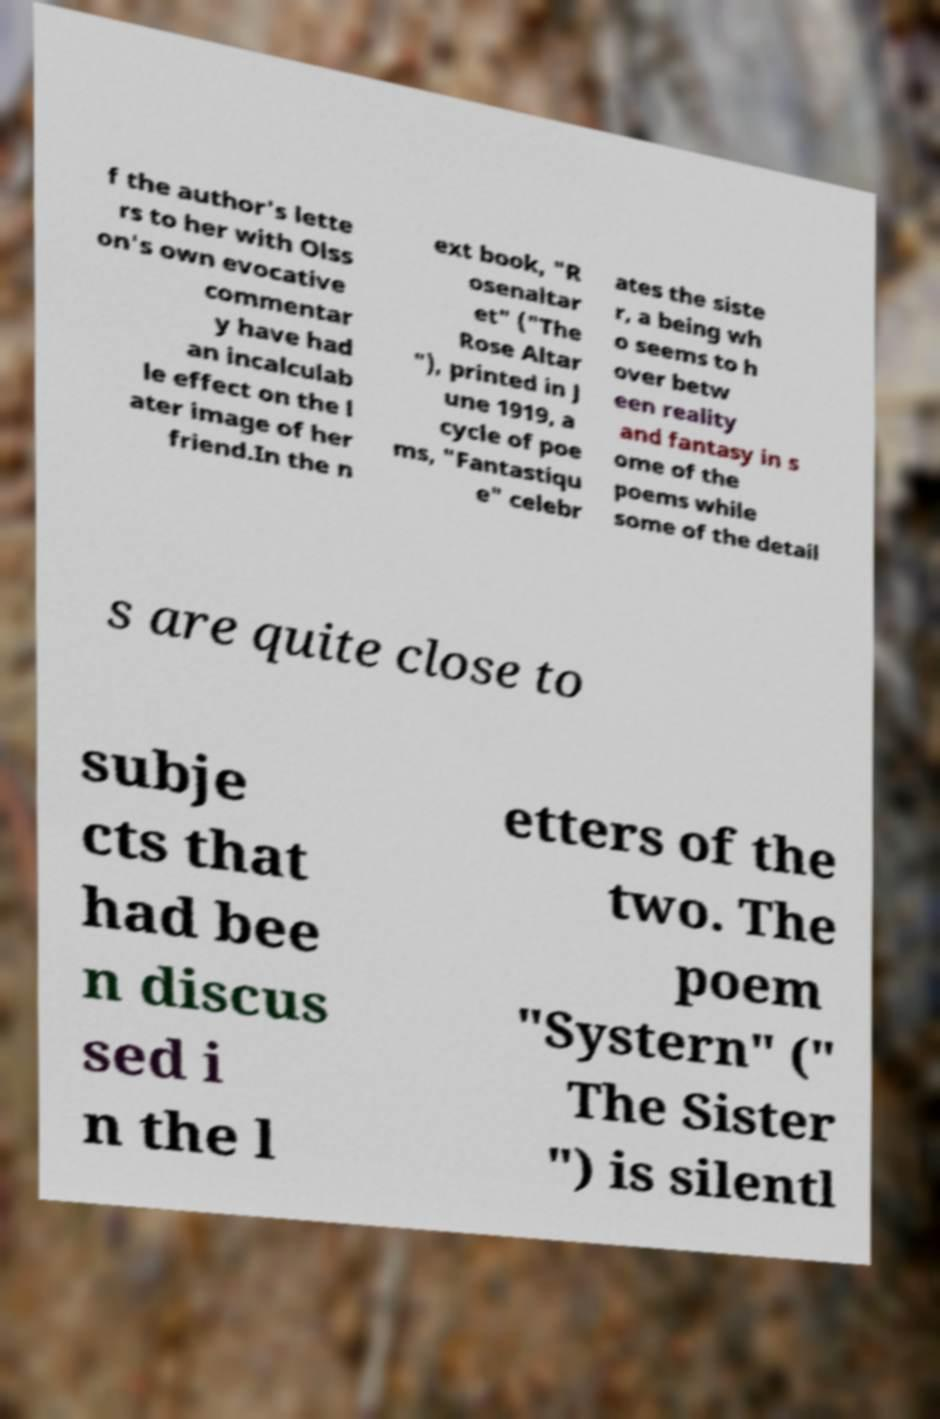There's text embedded in this image that I need extracted. Can you transcribe it verbatim? f the author's lette rs to her with Olss on's own evocative commentar y have had an incalculab le effect on the l ater image of her friend.In the n ext book, "R osenaltar et" ("The Rose Altar "), printed in J une 1919, a cycle of poe ms, "Fantastiqu e" celebr ates the siste r, a being wh o seems to h over betw een reality and fantasy in s ome of the poems while some of the detail s are quite close to subje cts that had bee n discus sed i n the l etters of the two. The poem "Systern" (" The Sister ") is silentl 